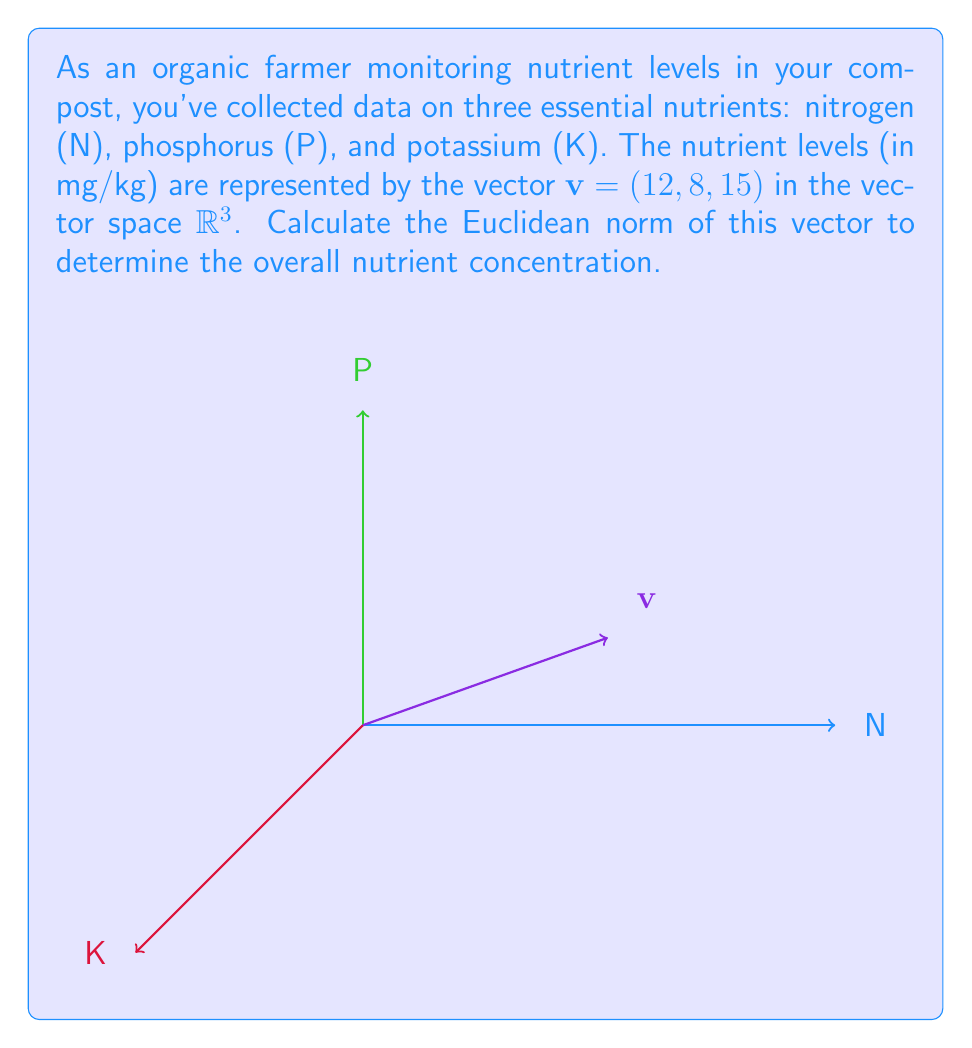Can you answer this question? To calculate the Euclidean norm of the vector $v = (12, 8, 15)$, we follow these steps:

1) The Euclidean norm (also known as L2 norm) of a vector $v = (x_1, x_2, ..., x_n)$ is defined as:

   $$\|v\| = \sqrt{\sum_{i=1}^n x_i^2}$$

2) For our vector $v = (12, 8, 15)$, we have:

   $$\|v\| = \sqrt{12^2 + 8^2 + 15^2}$$

3) Let's calculate the squares:
   
   $$\|v\| = \sqrt{144 + 64 + 225}$$

4) Sum the values under the square root:

   $$\|v\| = \sqrt{433}$$

5) Calculate the square root:

   $$\|v\| \approx 20.81$$

The Euclidean norm represents the straight-line distance from the origin to the point represented by the vector, giving us a single value that combines all three nutrient levels.
Answer: $\sqrt{433} \approx 20.81$ mg/kg 